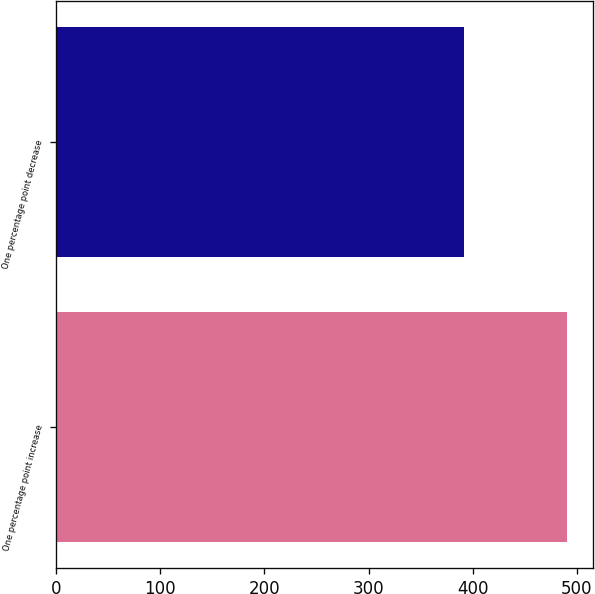Convert chart to OTSL. <chart><loc_0><loc_0><loc_500><loc_500><bar_chart><fcel>One percentage point increase<fcel>One percentage point decrease<nl><fcel>491<fcel>392<nl></chart> 